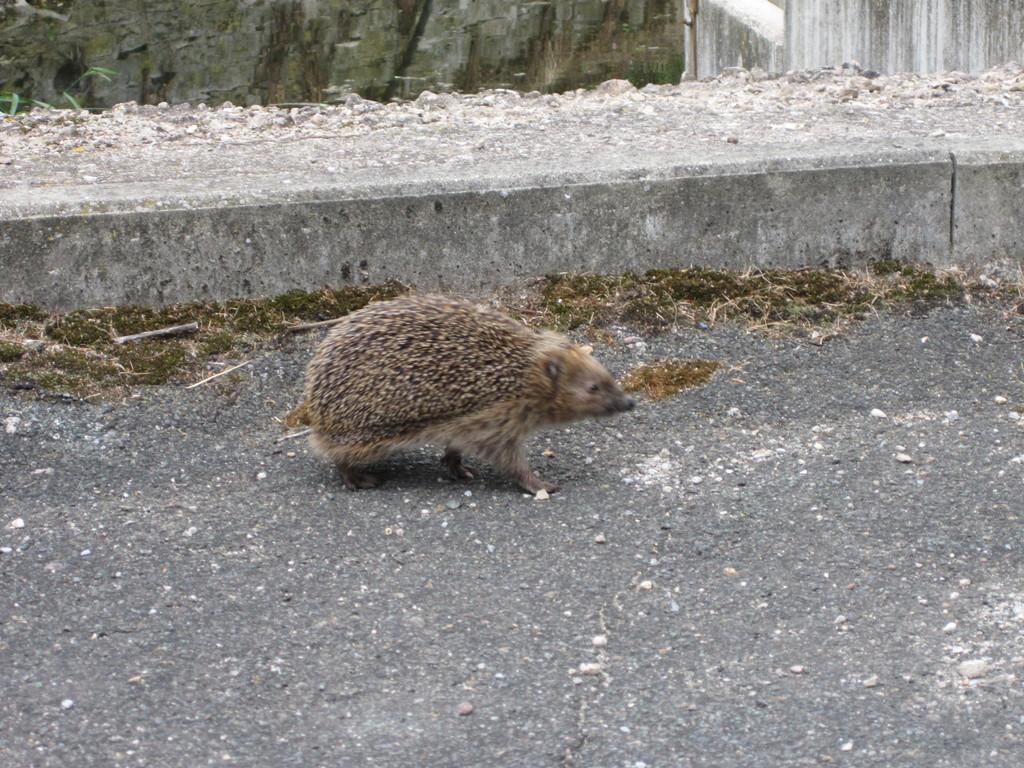How would you summarize this image in a sentence or two? In this picture I can see an animal in the middle, on the right side there are walls. 